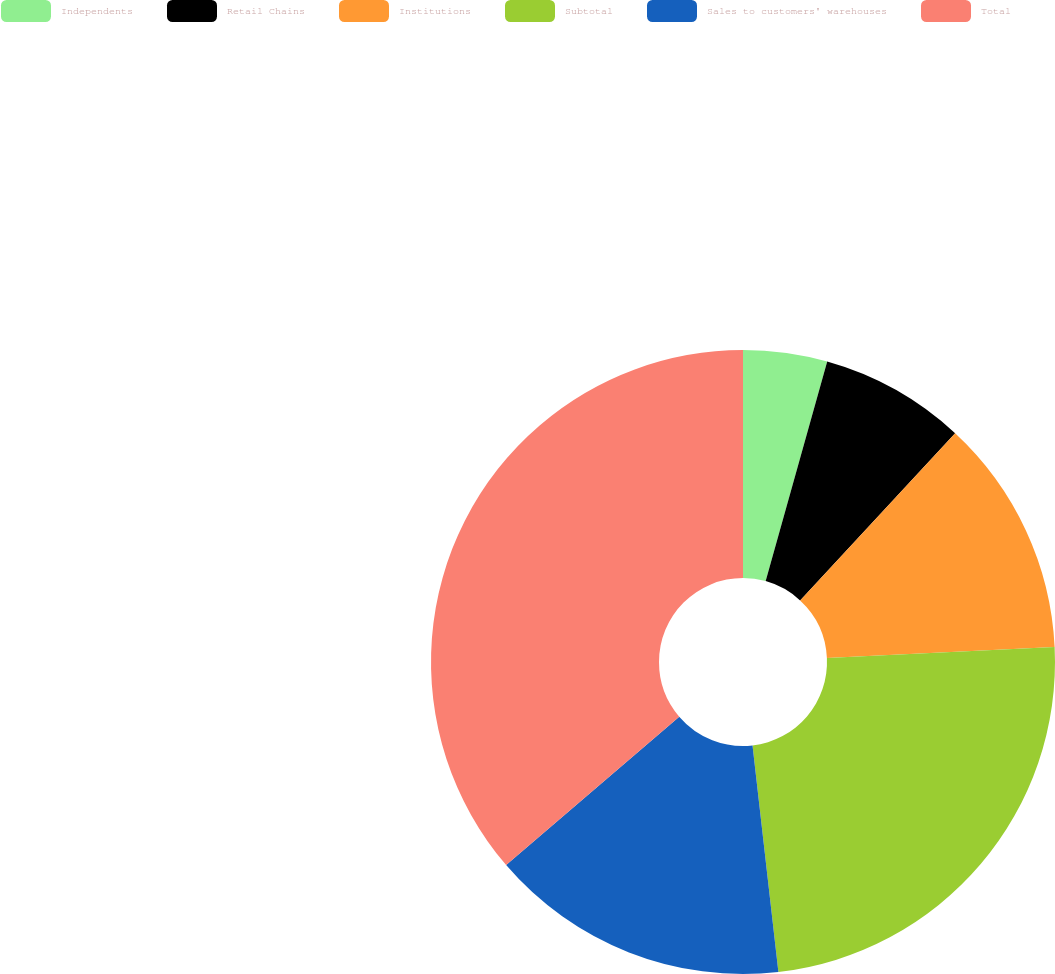Convert chart to OTSL. <chart><loc_0><loc_0><loc_500><loc_500><pie_chart><fcel>Independents<fcel>Retail Chains<fcel>Institutions<fcel>Subtotal<fcel>Sales to customers' warehouses<fcel>Total<nl><fcel>4.35%<fcel>7.55%<fcel>12.34%<fcel>23.95%<fcel>15.53%<fcel>36.28%<nl></chart> 